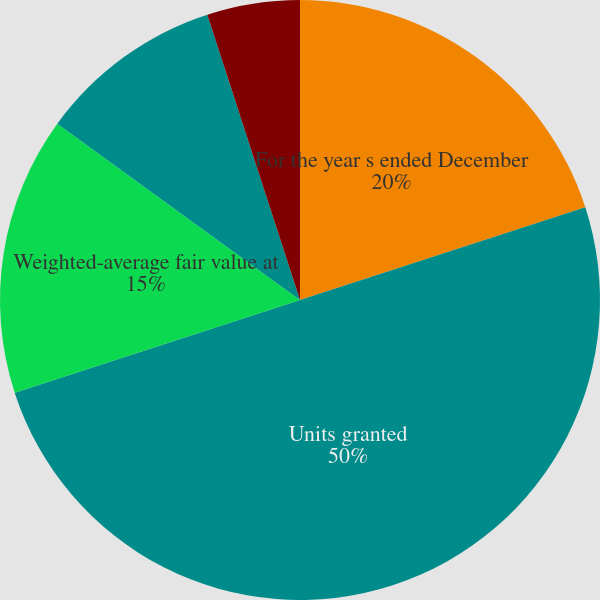<chart> <loc_0><loc_0><loc_500><loc_500><pie_chart><fcel>For the year s ended December<fcel>Units granted<fcel>Weighted-average fair value at<fcel>Estimated values<fcel>Dividend yields<fcel>Expected volatility<nl><fcel>20.0%<fcel>50.0%<fcel>15.0%<fcel>10.0%<fcel>0.0%<fcel>5.0%<nl></chart> 